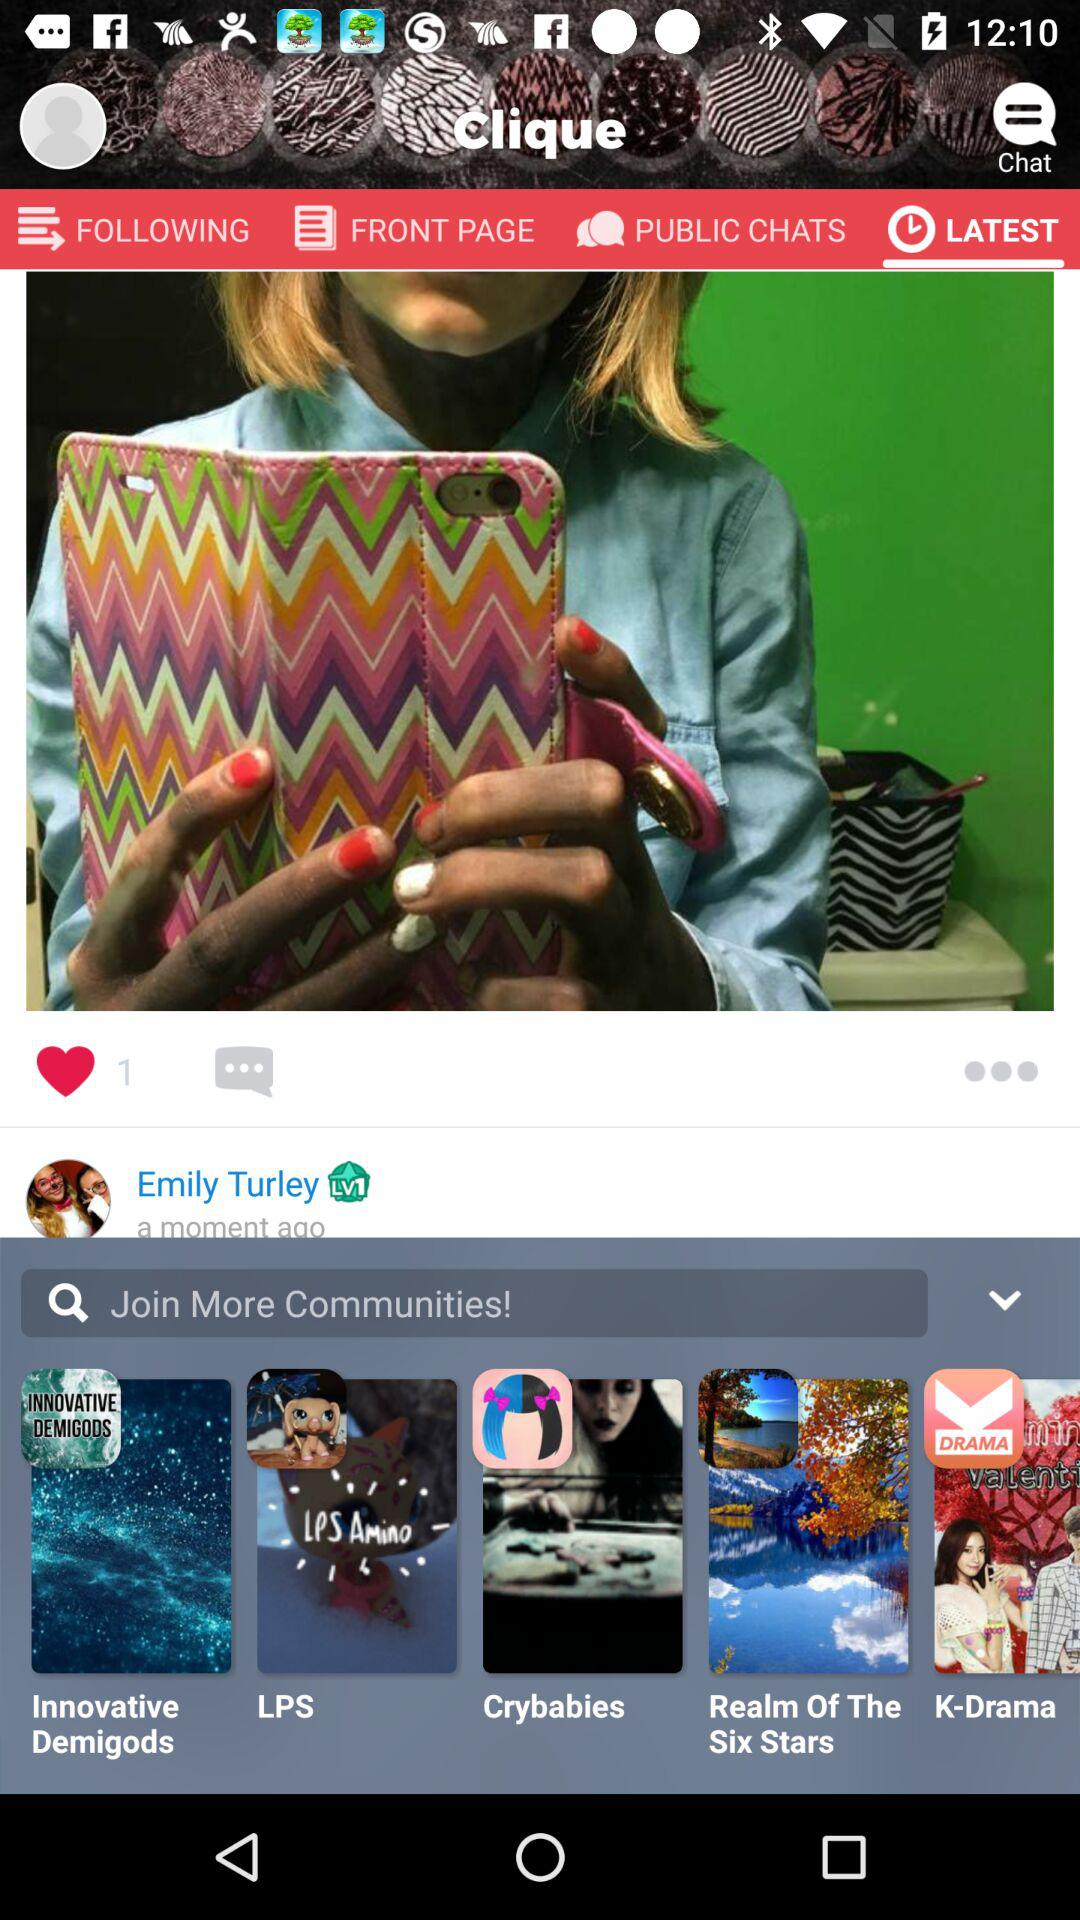How many likes are there? There is 1 like. 